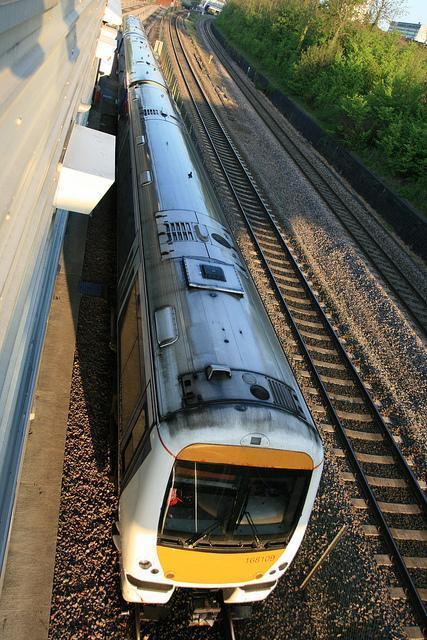How many birds are looking upward towards the sky?
Give a very brief answer. 0. 